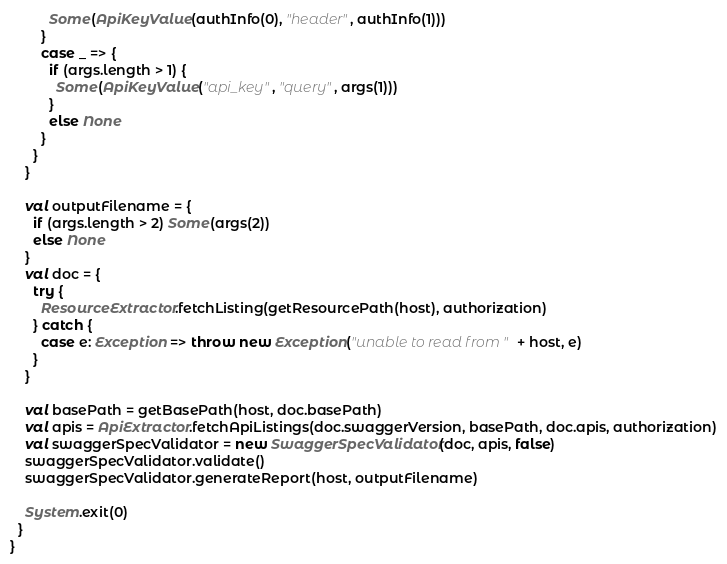<code> <loc_0><loc_0><loc_500><loc_500><_Scala_>          Some(ApiKeyValue(authInfo(0), "header", authInfo(1)))
        }
        case _ => {
          if (args.length > 1) {
            Some(ApiKeyValue("api_key", "query", args(1)))
          }
          else None
        }
      }
    }

    val outputFilename = {
      if (args.length > 2) Some(args(2))
      else None
    }
    val doc = {
      try {
        ResourceExtractor.fetchListing(getResourcePath(host), authorization)
      } catch {
        case e: Exception => throw new Exception("unable to read from " + host, e)
      }
    }

    val basePath = getBasePath(host, doc.basePath)
    val apis = ApiExtractor.fetchApiListings(doc.swaggerVersion, basePath, doc.apis, authorization)
    val swaggerSpecValidator = new SwaggerSpecValidator(doc, apis, false)
    swaggerSpecValidator.validate()
    swaggerSpecValidator.generateReport(host, outputFilename)

    System.exit(0)
  }
}
</code> 